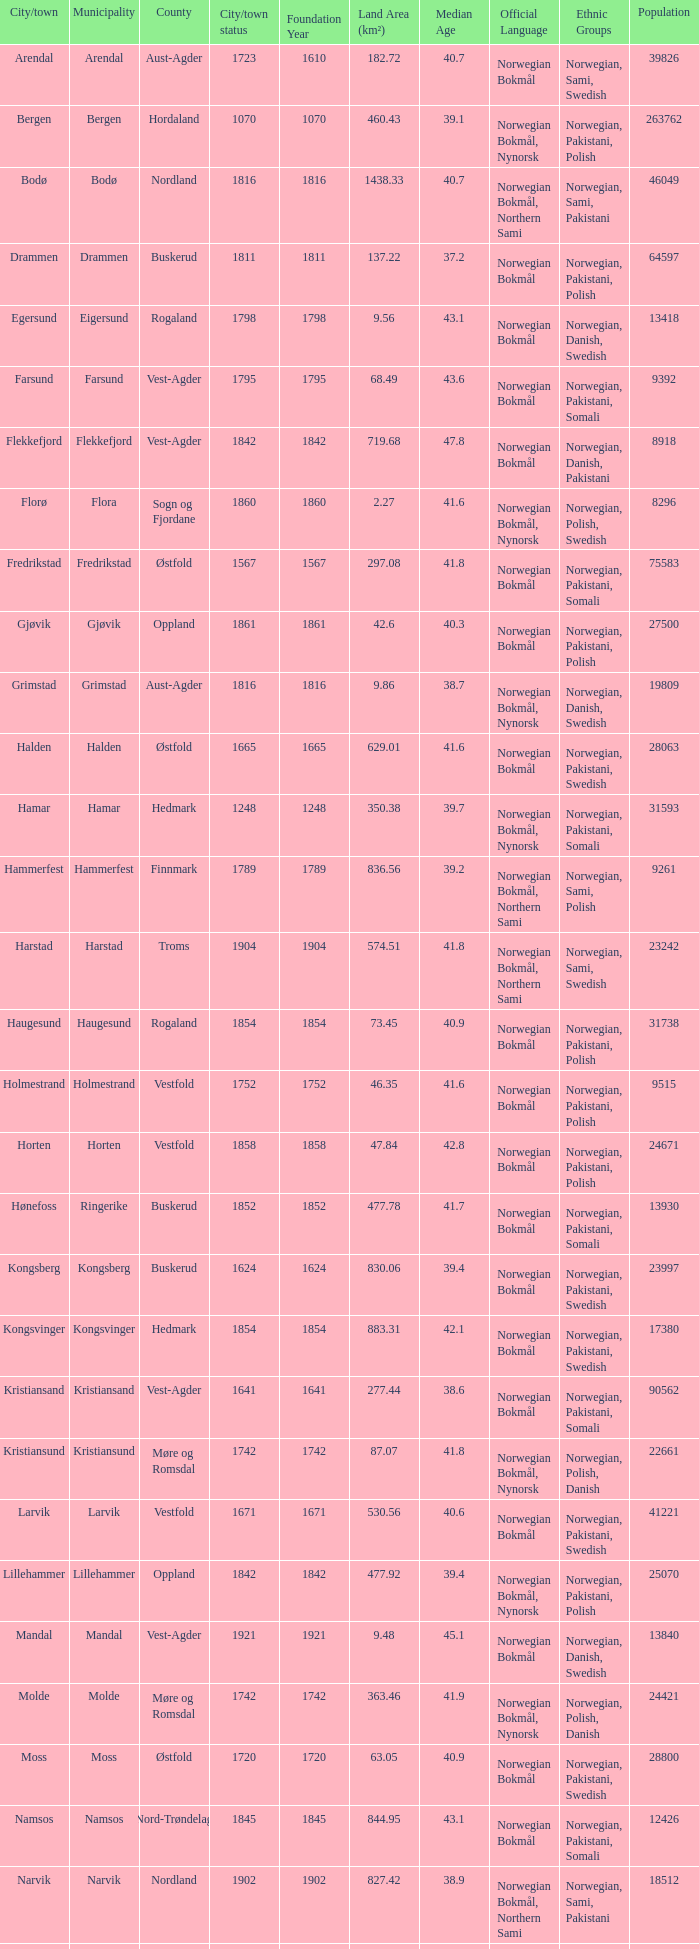In which county is the city/town of Halden located? Østfold. 